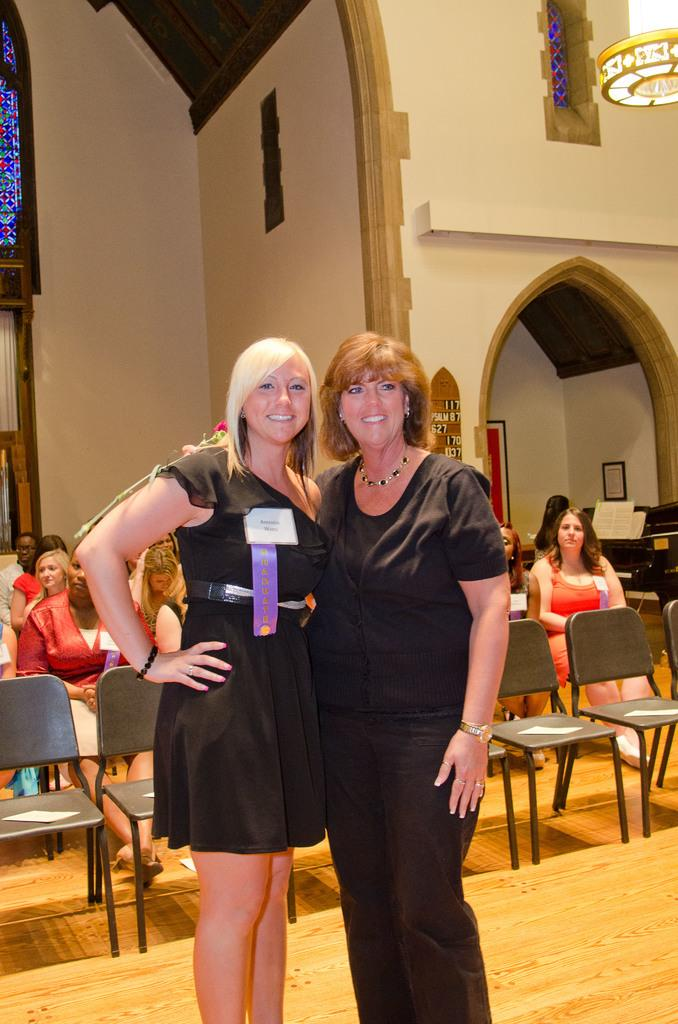How many ladies are in the image? There are two ladies in the image. What are the ladies wearing? The ladies are wearing black dresses. What else can be seen in the image besides the ladies? Chairs are visible in the image. Are the chairs occupied in the image? Yes, there are people sitting on the chairs in the image. What type of steel is used to construct the chairs in the image? There is no information about the chairs' construction material in the image, so it cannot be determined if steel is used. 